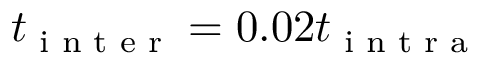<formula> <loc_0><loc_0><loc_500><loc_500>t _ { i n t e r } = 0 . 0 2 t _ { i n t r a }</formula> 